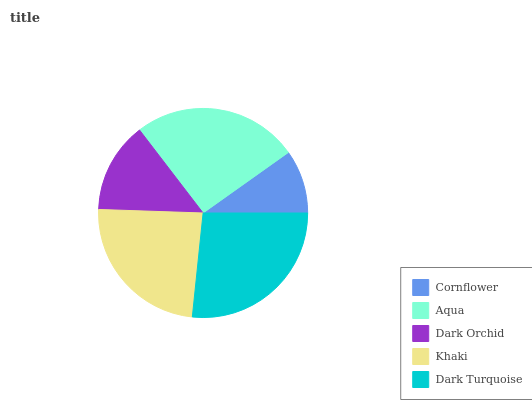Is Cornflower the minimum?
Answer yes or no. Yes. Is Dark Turquoise the maximum?
Answer yes or no. Yes. Is Aqua the minimum?
Answer yes or no. No. Is Aqua the maximum?
Answer yes or no. No. Is Aqua greater than Cornflower?
Answer yes or no. Yes. Is Cornflower less than Aqua?
Answer yes or no. Yes. Is Cornflower greater than Aqua?
Answer yes or no. No. Is Aqua less than Cornflower?
Answer yes or no. No. Is Khaki the high median?
Answer yes or no. Yes. Is Khaki the low median?
Answer yes or no. Yes. Is Dark Orchid the high median?
Answer yes or no. No. Is Dark Turquoise the low median?
Answer yes or no. No. 